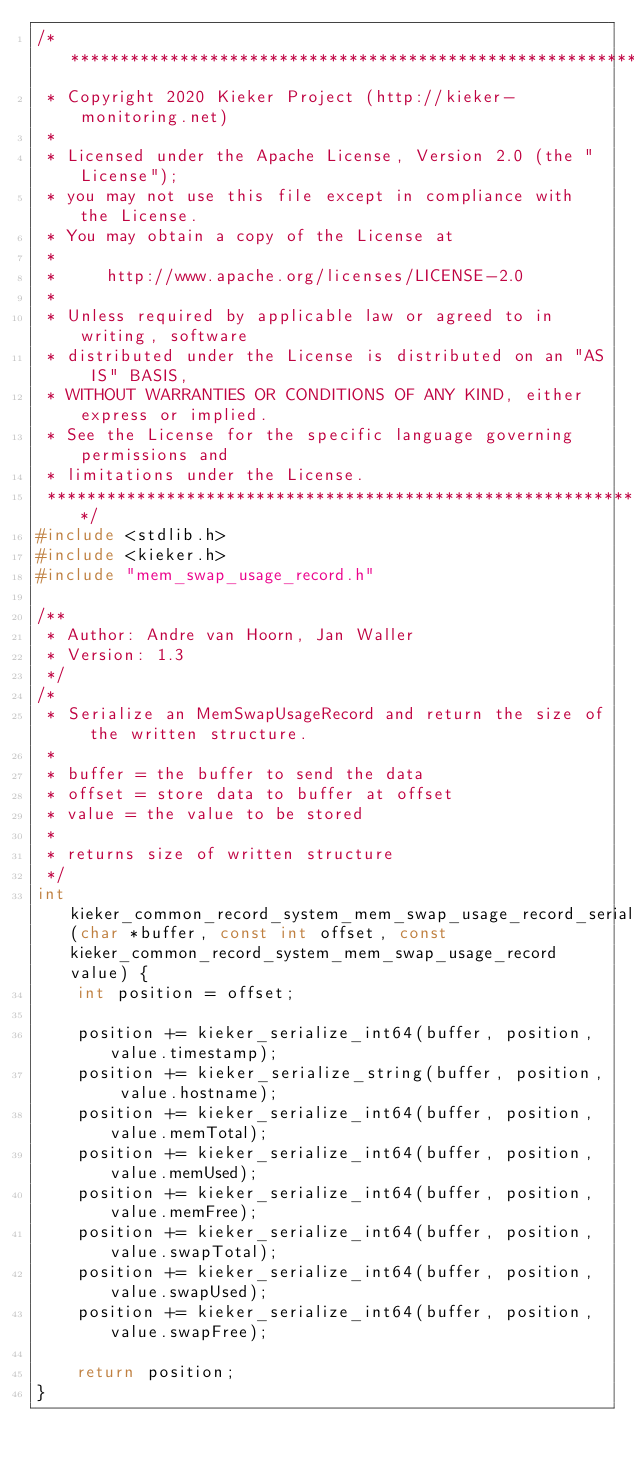<code> <loc_0><loc_0><loc_500><loc_500><_C_>/***************************************************************************
 * Copyright 2020 Kieker Project (http://kieker-monitoring.net)
 *
 * Licensed under the Apache License, Version 2.0 (the "License");
 * you may not use this file except in compliance with the License.
 * You may obtain a copy of the License at
 *
 *     http://www.apache.org/licenses/LICENSE-2.0
 *
 * Unless required by applicable law or agreed to in writing, software
 * distributed under the License is distributed on an "AS IS" BASIS,
 * WITHOUT WARRANTIES OR CONDITIONS OF ANY KIND, either express or implied.
 * See the License for the specific language governing permissions and
 * limitations under the License.
 ***************************************************************************/
#include <stdlib.h>
#include <kieker.h>
#include "mem_swap_usage_record.h"

/**
 * Author: Andre van Hoorn, Jan Waller
 * Version: 1.3
 */
/*
 * Serialize an MemSwapUsageRecord and return the size of the written structure.
 *
 * buffer = the buffer to send the data
 * offset = store data to buffer at offset
 * value = the value to be stored
 *
 * returns size of written structure
 */
int kieker_common_record_system_mem_swap_usage_record_serialize(char *buffer, const int offset, const kieker_common_record_system_mem_swap_usage_record value) {
	int position = offset;

	position += kieker_serialize_int64(buffer, position, value.timestamp);
	position += kieker_serialize_string(buffer, position, value.hostname);
	position += kieker_serialize_int64(buffer, position, value.memTotal);
	position += kieker_serialize_int64(buffer, position, value.memUsed);
	position += kieker_serialize_int64(buffer, position, value.memFree);
	position += kieker_serialize_int64(buffer, position, value.swapTotal);
	position += kieker_serialize_int64(buffer, position, value.swapUsed);
	position += kieker_serialize_int64(buffer, position, value.swapFree);

	return position;
}
</code> 